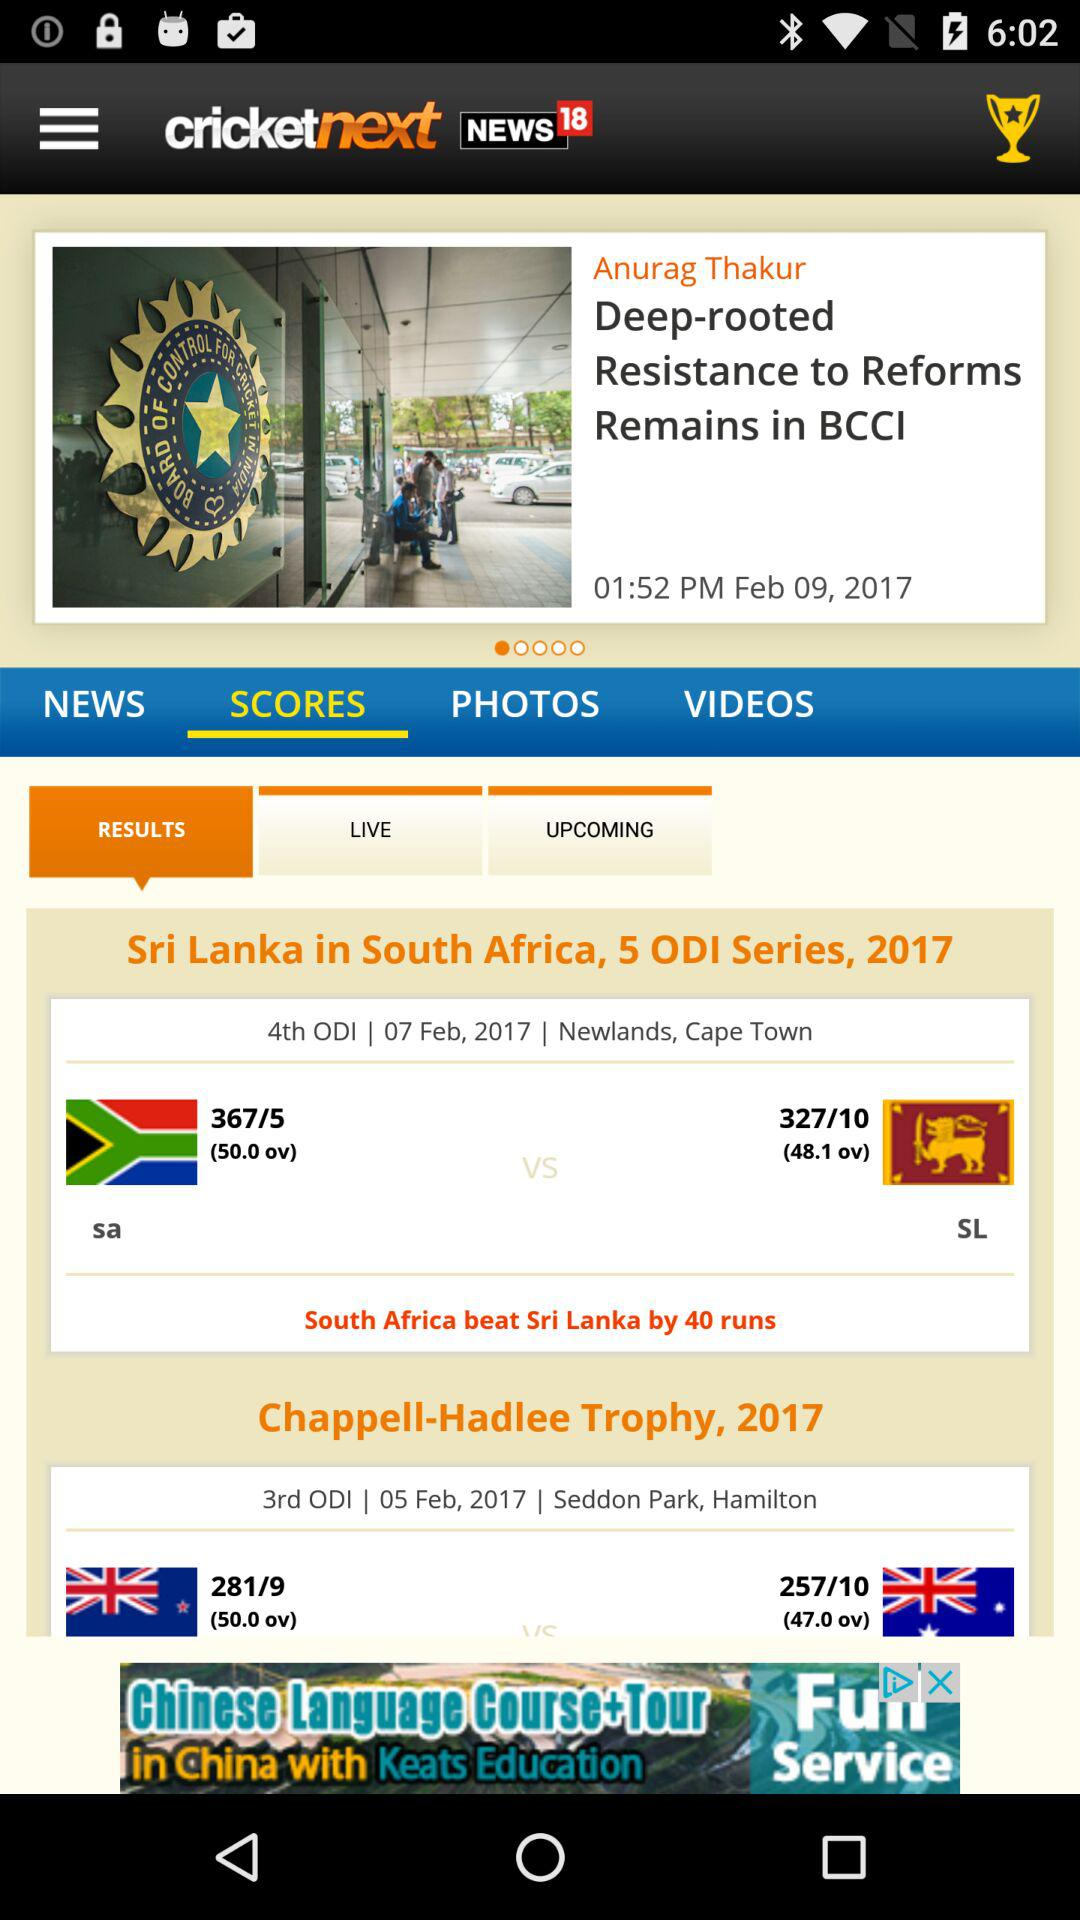How many runs did "Sri Lanka" score? "Sri Lanka" scored 327 runs. 